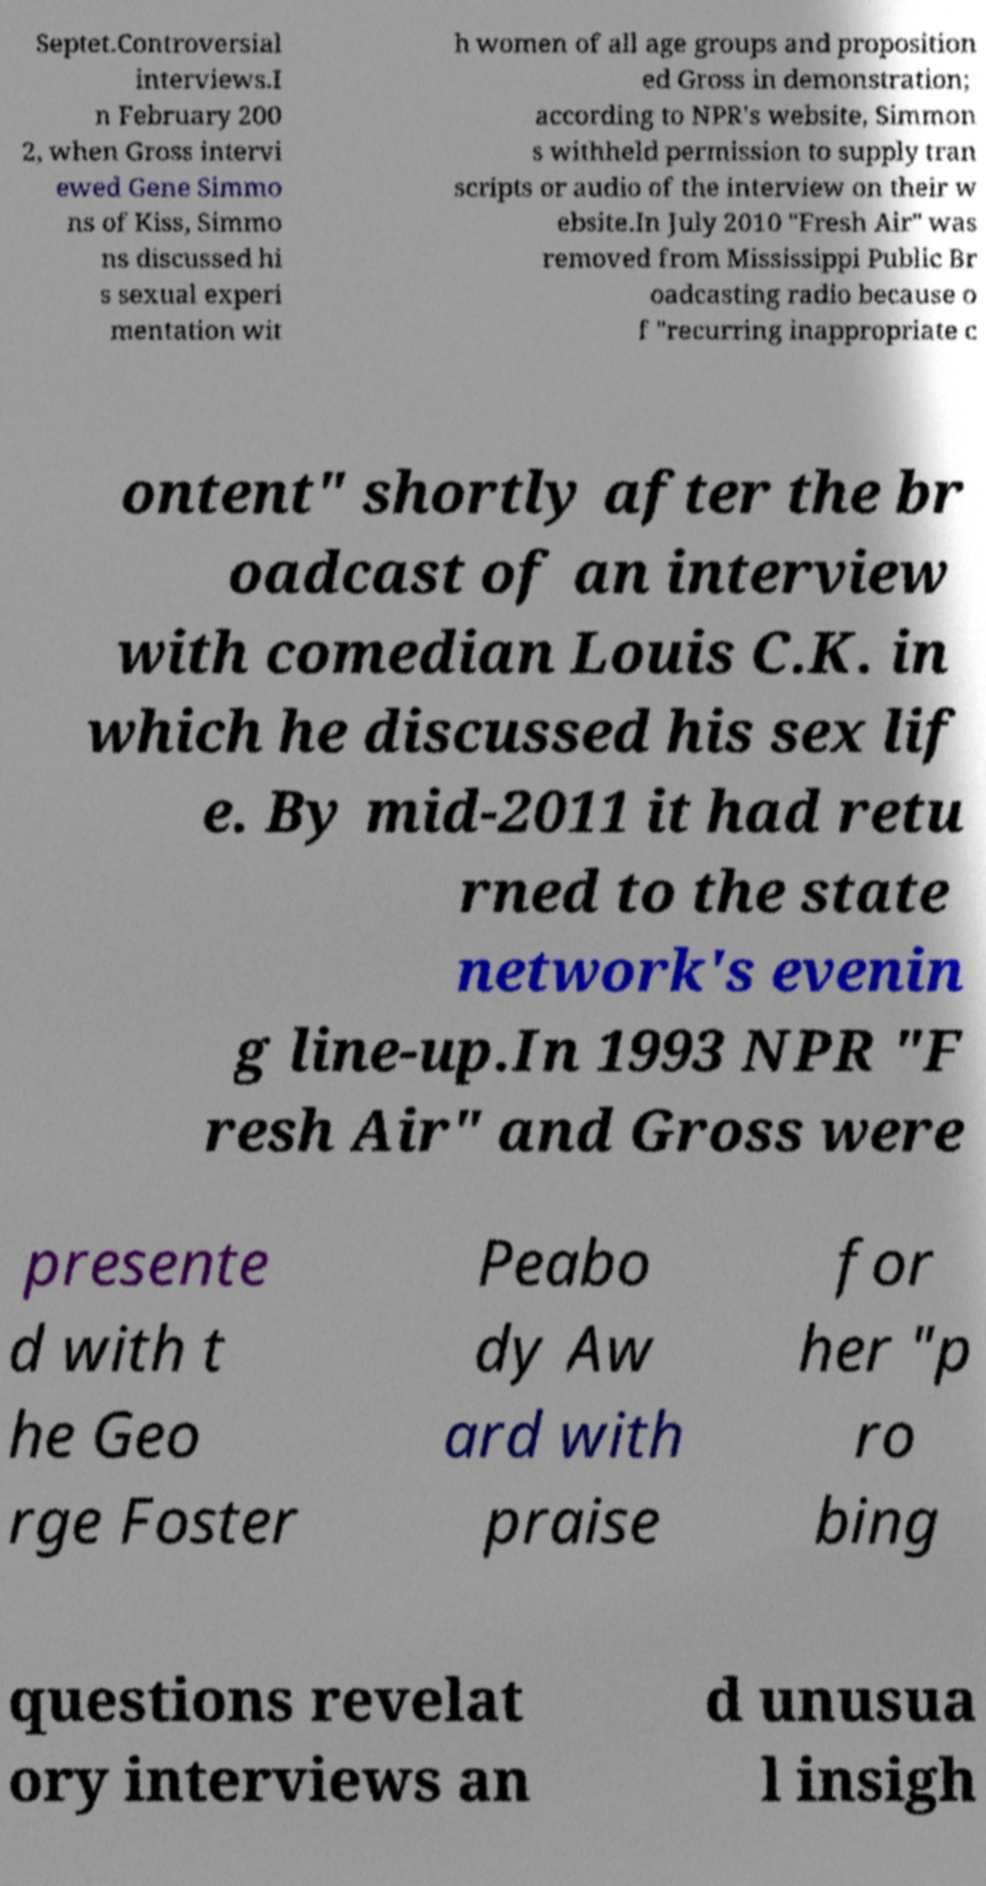There's text embedded in this image that I need extracted. Can you transcribe it verbatim? Septet.Controversial interviews.I n February 200 2, when Gross intervi ewed Gene Simmo ns of Kiss, Simmo ns discussed hi s sexual experi mentation wit h women of all age groups and proposition ed Gross in demonstration; according to NPR's website, Simmon s withheld permission to supply tran scripts or audio of the interview on their w ebsite.In July 2010 "Fresh Air" was removed from Mississippi Public Br oadcasting radio because o f "recurring inappropriate c ontent" shortly after the br oadcast of an interview with comedian Louis C.K. in which he discussed his sex lif e. By mid-2011 it had retu rned to the state network's evenin g line-up.In 1993 NPR "F resh Air" and Gross were presente d with t he Geo rge Foster Peabo dy Aw ard with praise for her "p ro bing questions revelat ory interviews an d unusua l insigh 